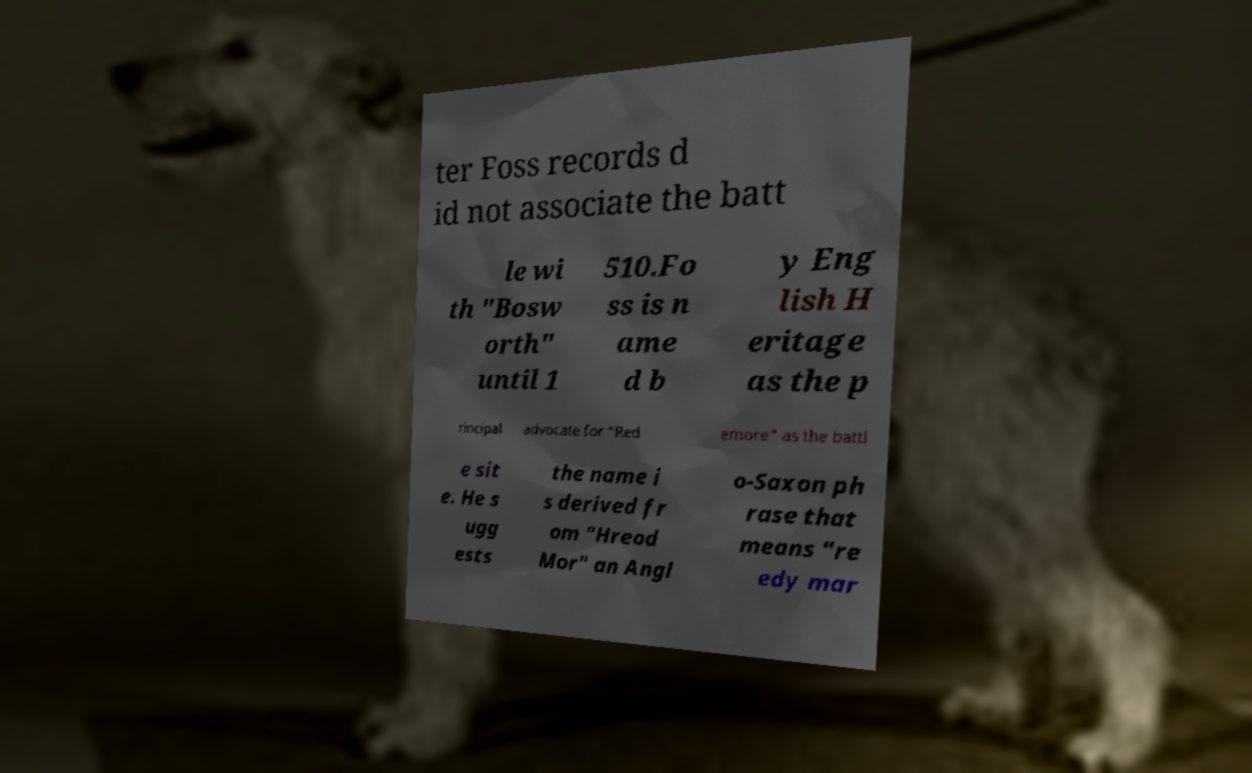Please read and relay the text visible in this image. What does it say? ter Foss records d id not associate the batt le wi th "Bosw orth" until 1 510.Fo ss is n ame d b y Eng lish H eritage as the p rincipal advocate for "Red emore" as the battl e sit e. He s ugg ests the name i s derived fr om "Hreod Mor" an Angl o-Saxon ph rase that means "re edy mar 